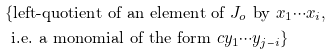<formula> <loc_0><loc_0><loc_500><loc_500>& \{ \text {left-quotient of an element of } J _ { o } \text { by } x _ { 1 } \cdots x _ { i } , \\ & \text { i.e. a monomial of the form } c y _ { 1 } \cdots y _ { j - i } \}</formula> 